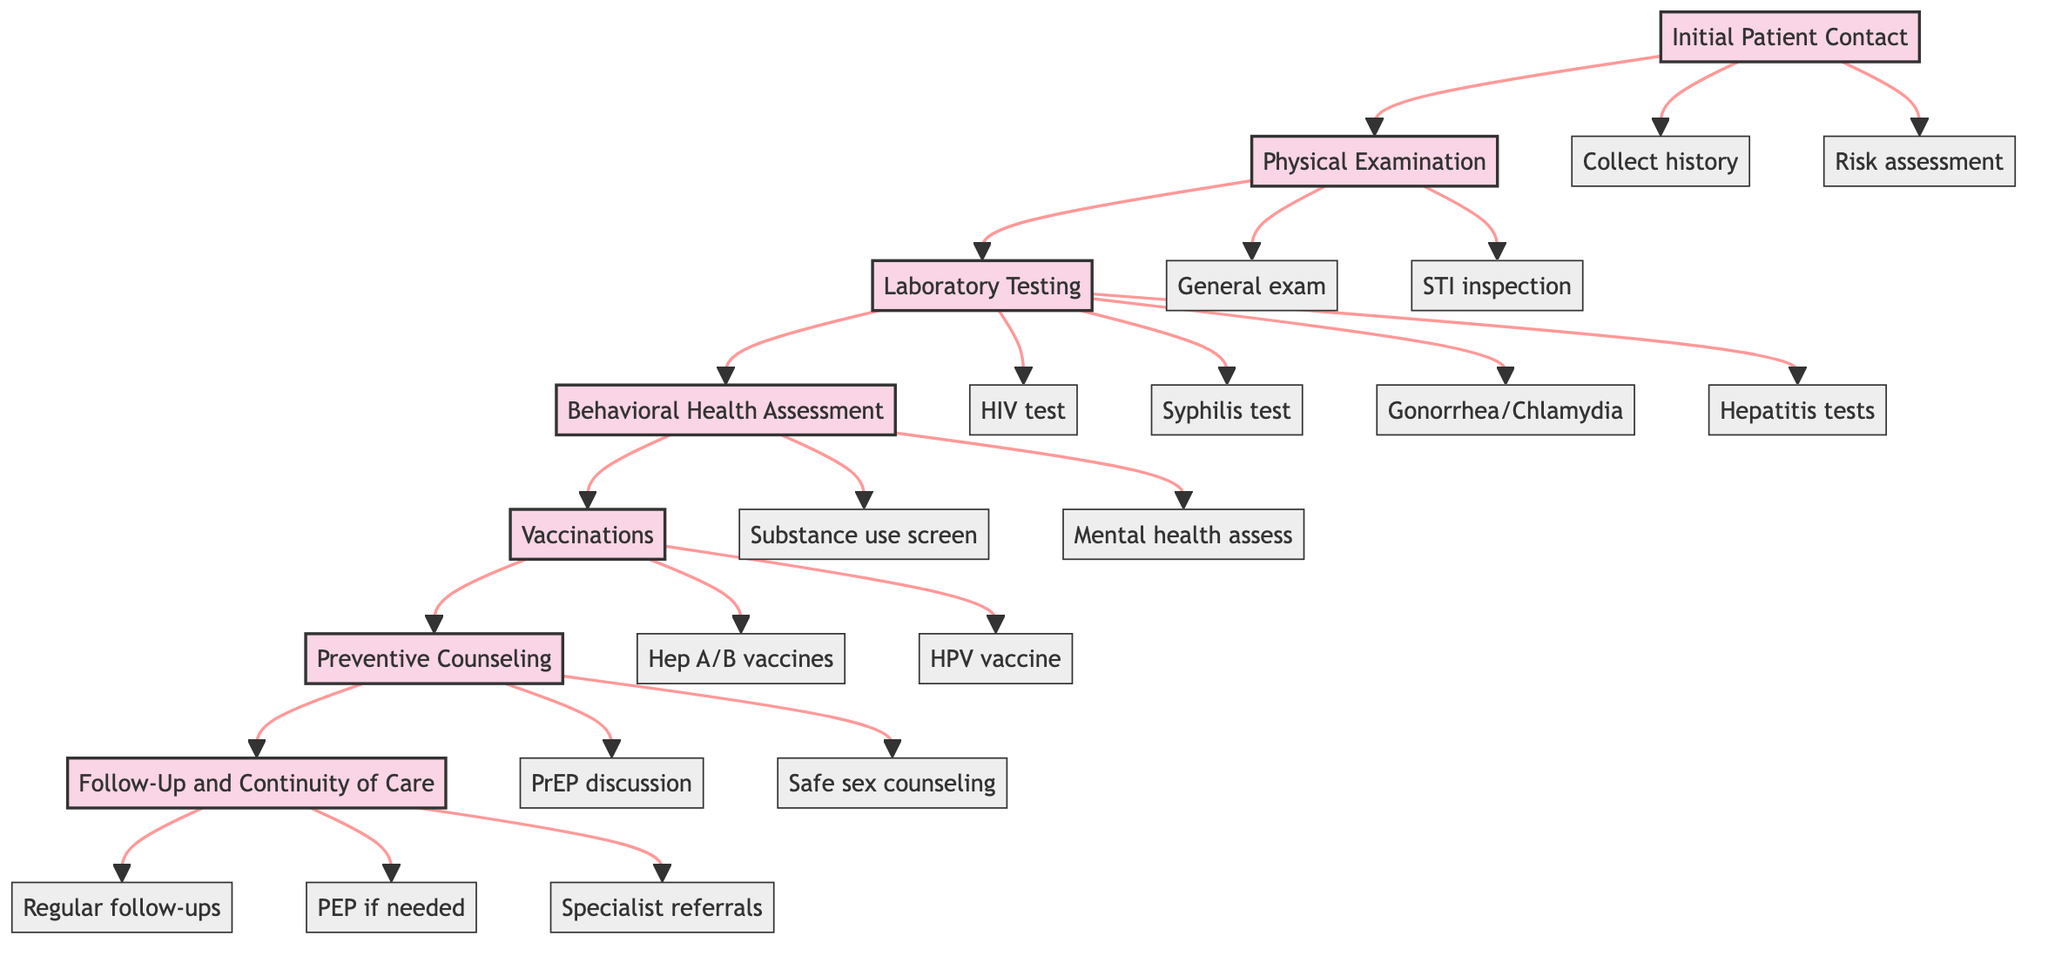What is the first step in the clinical pathway? The first step is labeled "Initial Patient Contact" in the diagram.
Answer: Initial Patient Contact How many actions are included in the "Laboratory Testing" step? The "Laboratory Testing" step has four actions listed: HIV testing, syphilis serology, gonorrhea/chlamydia testing, and hepatitis testing.
Answer: Four Which step follows the "Preventive Counseling"? The step that follows "Preventive Counseling" is "Follow-Up and Continuity of Care." This relationship can be traced through the directional arrows indicating flow.
Answer: Follow-Up and Continuity of Care What type of vaccines are provided in the Vaccinations step? The "Vaccinations" step includes Hepatitis A and B vaccinations and HPV vaccination. This is specified under the actions for that step.
Answer: Hepatitis A, B, and HPV vaccines How many total steps are there in the clinical pathway? Counting the nodes in the diagram, there are seven distinct steps from the initial contact to follow-up care.
Answer: Seven What action follows the "Behavioral Health Assessment" step? The action directly following "Behavioral Health Assessment" is "Vaccinations." This can be confirmed by following the arrows in the diagram.
Answer: Vaccinations Which step includes discussing PrEP? The "Preventive Counseling" step includes the action of discussing PrEP, as indicated in the actions listed under that step.
Answer: Preventive Counseling Is the substance use screening part of a physical examination? No, substance use screening is part of the "Behavioral Health Assessment" step, not the "Physical Examination" step. This is clear upon reviewing the grouping of actions.
Answer: No What is the last action listed in the diagram? The last action in the flow of the diagram is "Specialist referrals," which is associated with the "Follow-Up and Continuity of Care" step.
Answer: Specialist referrals 